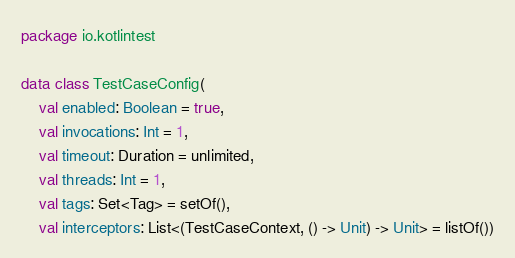Convert code to text. <code><loc_0><loc_0><loc_500><loc_500><_Kotlin_>package io.kotlintest

data class TestCaseConfig(
    val enabled: Boolean = true,
    val invocations: Int = 1,
    val timeout: Duration = unlimited,
    val threads: Int = 1,
    val tags: Set<Tag> = setOf(),
    val interceptors: List<(TestCaseContext, () -> Unit) -> Unit> = listOf())</code> 